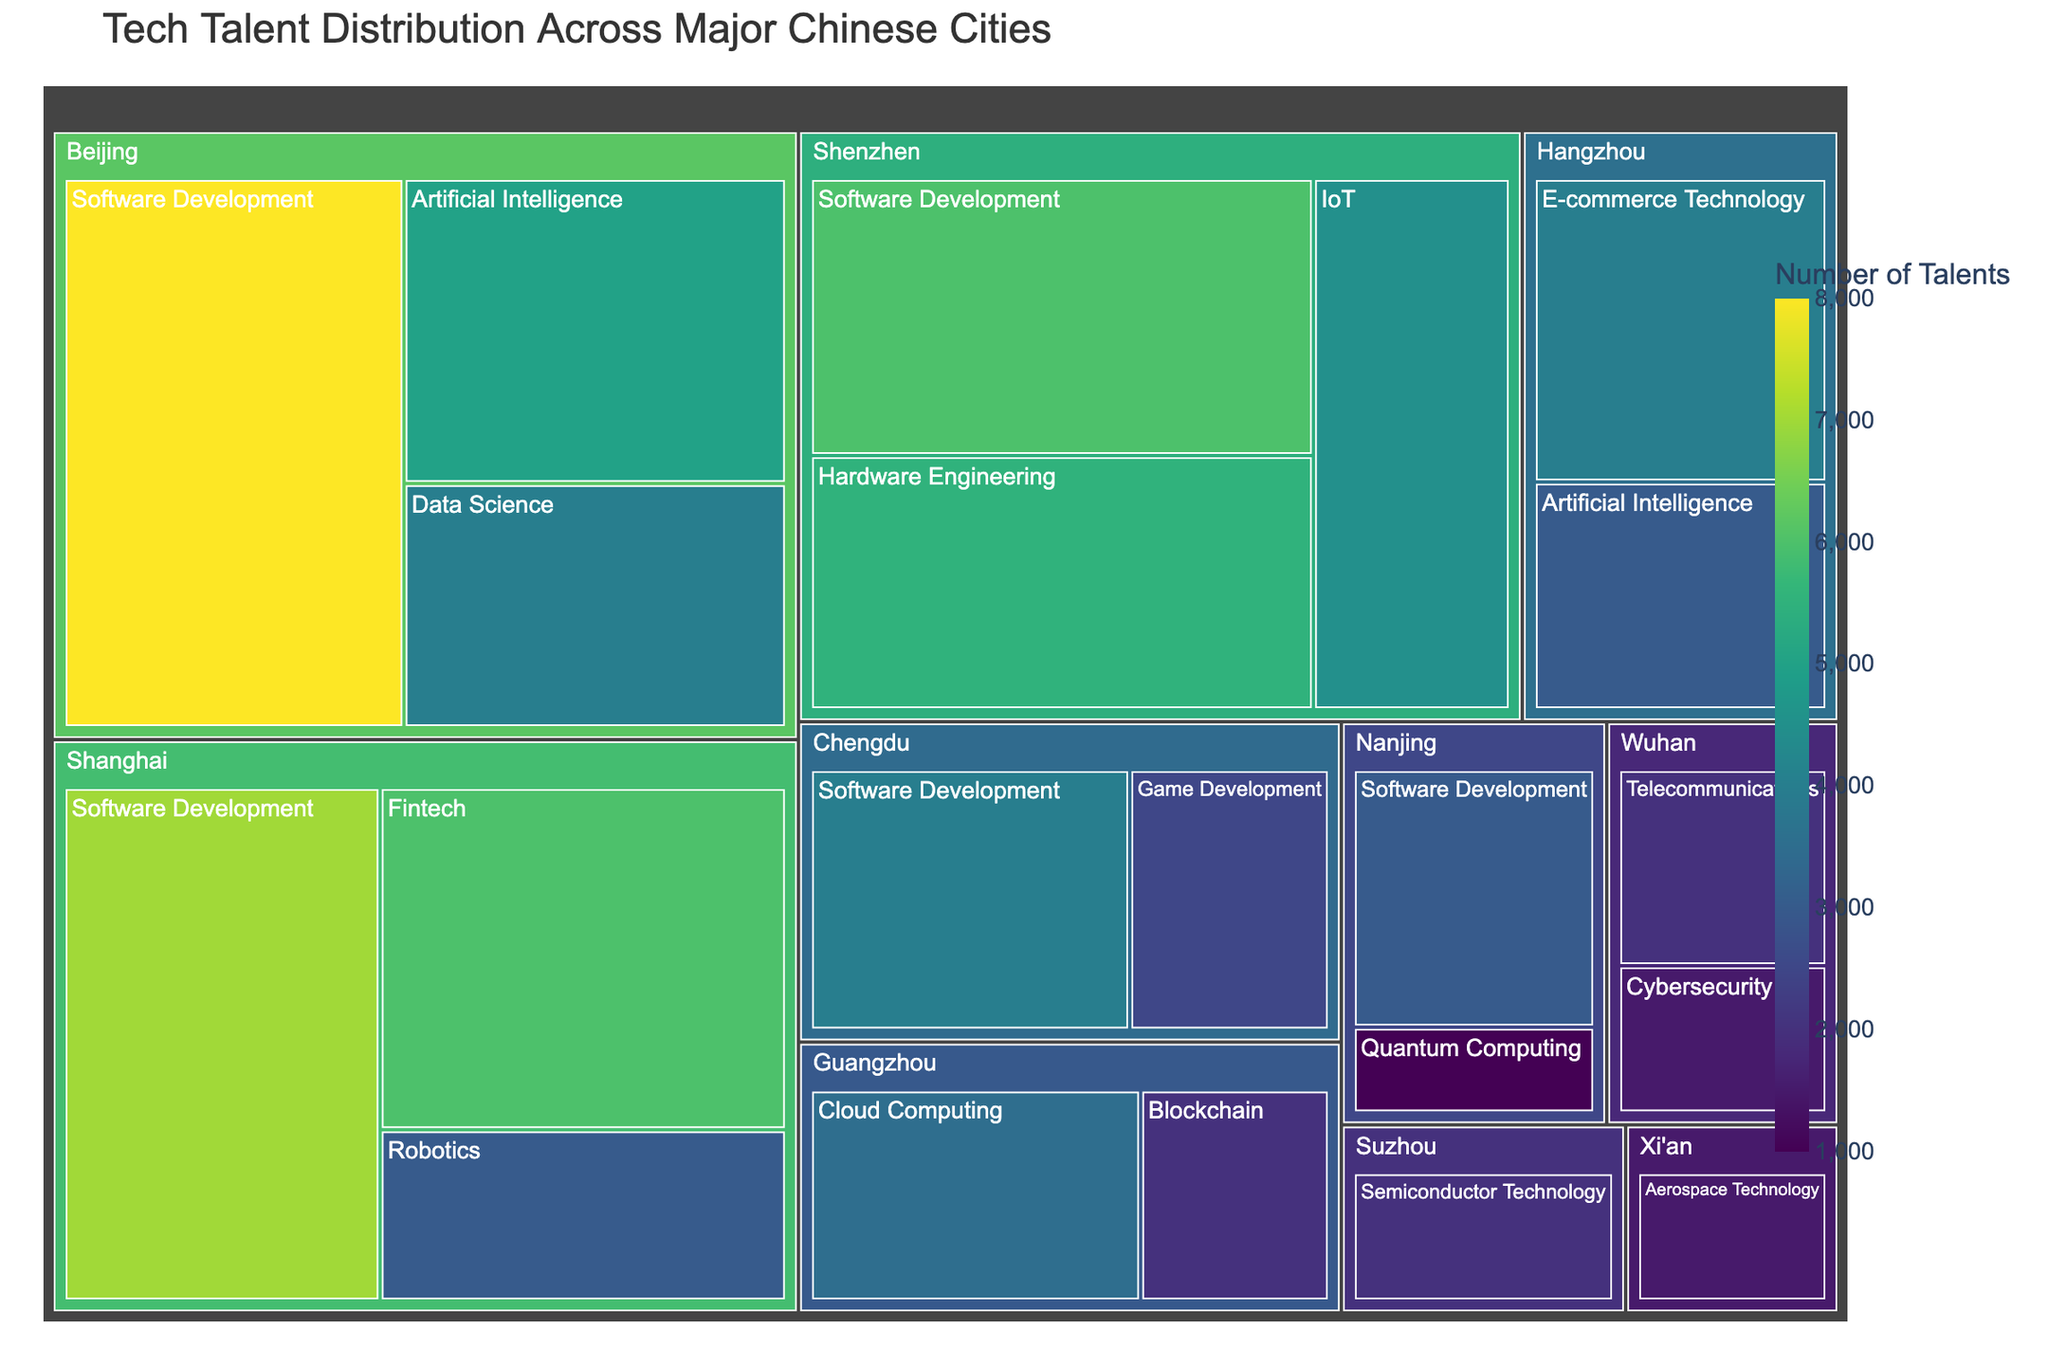what is the city with the highest number of tech talents? By looking at the color intensity and size of the sections in the treemap, Beijing has the largest sections, representing the highest number of tech talents.
Answer: Beijing Which specialization in Beijing has the most tech talents? According to the size of the boxes within Beijing's section, Software Development has the largest box, indicating it has the most tech talents in Beijing.
Answer: Software Development How many tech talents specialize in IoT in Shenzhen? Locate the Shenzhen section in the treemap and check the number displayed within or hover over the IoT box to see the total number, which is 4500.
Answer: 4500 What is the total number of tech talents in Shanghai? Add up the numbers for all specializations within Shanghai: 6000 (Fintech) + 3000 (Robotics) + 7000 (Software Development) = 16000.
Answer: 16000 Which city has the least number of tech talents specializing in Quantum Computing? Find the Quantum Computing section, which is within Nanjing, containing a single box with the number 1000.
Answer: Nanjing Which specialization is unique to Xi'an? From the treemap, find the Xi'an section and see that only Aerospace Technology is present.
Answer: Aerospace Technology How does the number of tech talents in Artificial Intelligence compare between Beijing and Hangzhou? Beijing's Artificial Intelligence section shows 5000, and Hangzhou's shows 3000, so Beijing has more Artificial Intelligence tech talents.
Answer: Beijing has more What is the difference in the number of Software Development tech talents between Beijing and Shanghai? Beijing has 8000 and Shanghai has 7000 Software Development tech talents, so the difference is 8000 - 7000 = 1000.
Answer: 1000 Which city has a higher number of Cybersecurity tech talents, Chengdu or Wuhan? Wuhan has a section labeled Cybersecurity with 1500 tech talents, and Chengdu has none, so Wuhan has more.
Answer: Wuhan What is the total number of tech talents in Software Development across all cities? Sum the numbers for Software Development in all cities: 8000 (Beijing) + 7000 (Shanghai) + 6000 (Shenzhen) + 4000 (Chengdu) + 3000 (Nanjing) = 28000.
Answer: 28000 